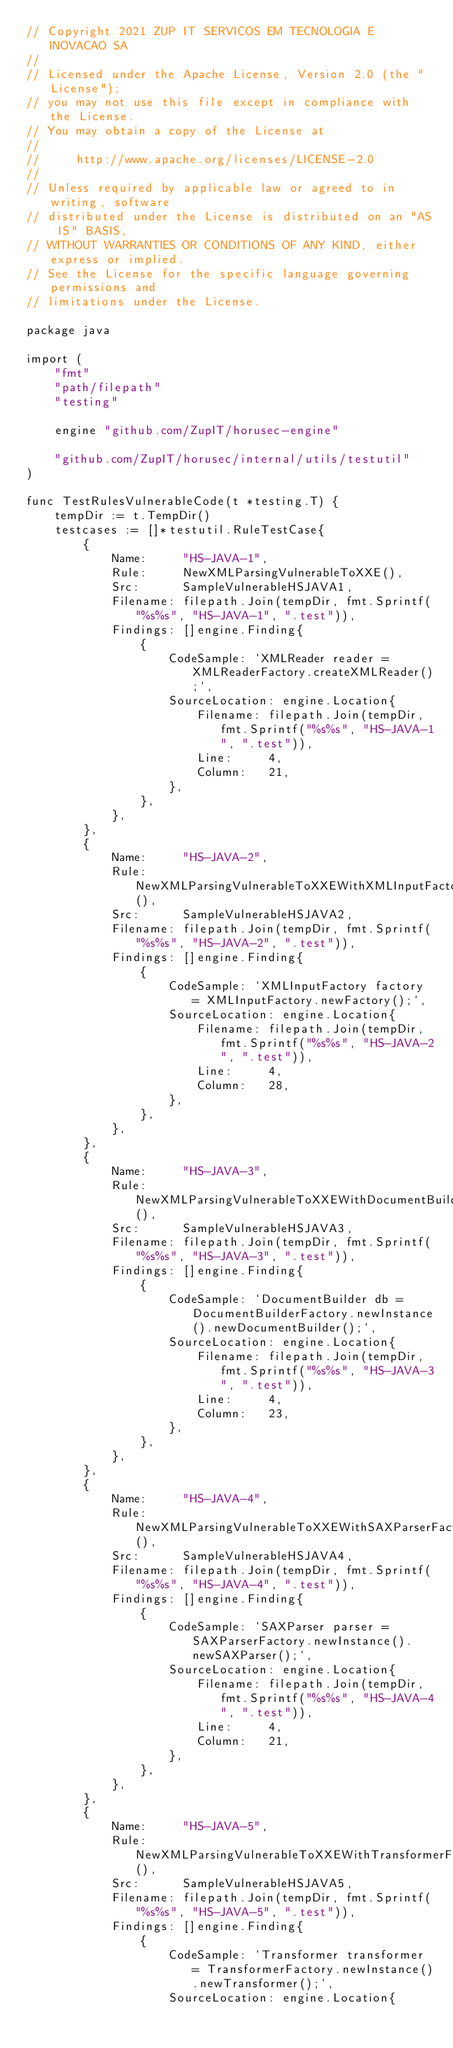Convert code to text. <code><loc_0><loc_0><loc_500><loc_500><_Go_>// Copyright 2021 ZUP IT SERVICOS EM TECNOLOGIA E INOVACAO SA
//
// Licensed under the Apache License, Version 2.0 (the "License");
// you may not use this file except in compliance with the License.
// You may obtain a copy of the License at
//
//     http://www.apache.org/licenses/LICENSE-2.0
//
// Unless required by applicable law or agreed to in writing, software
// distributed under the License is distributed on an "AS IS" BASIS,
// WITHOUT WARRANTIES OR CONDITIONS OF ANY KIND, either express or implied.
// See the License for the specific language governing permissions and
// limitations under the License.

package java

import (
	"fmt"
	"path/filepath"
	"testing"

	engine "github.com/ZupIT/horusec-engine"

	"github.com/ZupIT/horusec/internal/utils/testutil"
)

func TestRulesVulnerableCode(t *testing.T) {
	tempDir := t.TempDir()
	testcases := []*testutil.RuleTestCase{
		{
			Name:     "HS-JAVA-1",
			Rule:     NewXMLParsingVulnerableToXXE(),
			Src:      SampleVulnerableHSJAVA1,
			Filename: filepath.Join(tempDir, fmt.Sprintf("%s%s", "HS-JAVA-1", ".test")),
			Findings: []engine.Finding{
				{
					CodeSample: `XMLReader reader = XMLReaderFactory.createXMLReader();`,
					SourceLocation: engine.Location{
						Filename: filepath.Join(tempDir, fmt.Sprintf("%s%s", "HS-JAVA-1", ".test")),
						Line:     4,
						Column:   21,
					},
				},
			},
		},
		{
			Name:     "HS-JAVA-2",
			Rule:     NewXMLParsingVulnerableToXXEWithXMLInputFactory(),
			Src:      SampleVulnerableHSJAVA2,
			Filename: filepath.Join(tempDir, fmt.Sprintf("%s%s", "HS-JAVA-2", ".test")),
			Findings: []engine.Finding{
				{
					CodeSample: `XMLInputFactory factory = XMLInputFactory.newFactory();`,
					SourceLocation: engine.Location{
						Filename: filepath.Join(tempDir, fmt.Sprintf("%s%s", "HS-JAVA-2", ".test")),
						Line:     4,
						Column:   28,
					},
				},
			},
		},
		{
			Name:     "HS-JAVA-3",
			Rule:     NewXMLParsingVulnerableToXXEWithDocumentBuilder(),
			Src:      SampleVulnerableHSJAVA3,
			Filename: filepath.Join(tempDir, fmt.Sprintf("%s%s", "HS-JAVA-3", ".test")),
			Findings: []engine.Finding{
				{
					CodeSample: `DocumentBuilder db = DocumentBuilderFactory.newInstance().newDocumentBuilder();`,
					SourceLocation: engine.Location{
						Filename: filepath.Join(tempDir, fmt.Sprintf("%s%s", "HS-JAVA-3", ".test")),
						Line:     4,
						Column:   23,
					},
				},
			},
		},
		{
			Name:     "HS-JAVA-4",
			Rule:     NewXMLParsingVulnerableToXXEWithSAXParserFactory(),
			Src:      SampleVulnerableHSJAVA4,
			Filename: filepath.Join(tempDir, fmt.Sprintf("%s%s", "HS-JAVA-4", ".test")),
			Findings: []engine.Finding{
				{
					CodeSample: `SAXParser parser = SAXParserFactory.newInstance().newSAXParser();`,
					SourceLocation: engine.Location{
						Filename: filepath.Join(tempDir, fmt.Sprintf("%s%s", "HS-JAVA-4", ".test")),
						Line:     4,
						Column:   21,
					},
				},
			},
		},
		{
			Name:     "HS-JAVA-5",
			Rule:     NewXMLParsingVulnerableToXXEWithTransformerFactory(),
			Src:      SampleVulnerableHSJAVA5,
			Filename: filepath.Join(tempDir, fmt.Sprintf("%s%s", "HS-JAVA-5", ".test")),
			Findings: []engine.Finding{
				{
					CodeSample: `Transformer transformer = TransformerFactory.newInstance().newTransformer();`,
					SourceLocation: engine.Location{</code> 